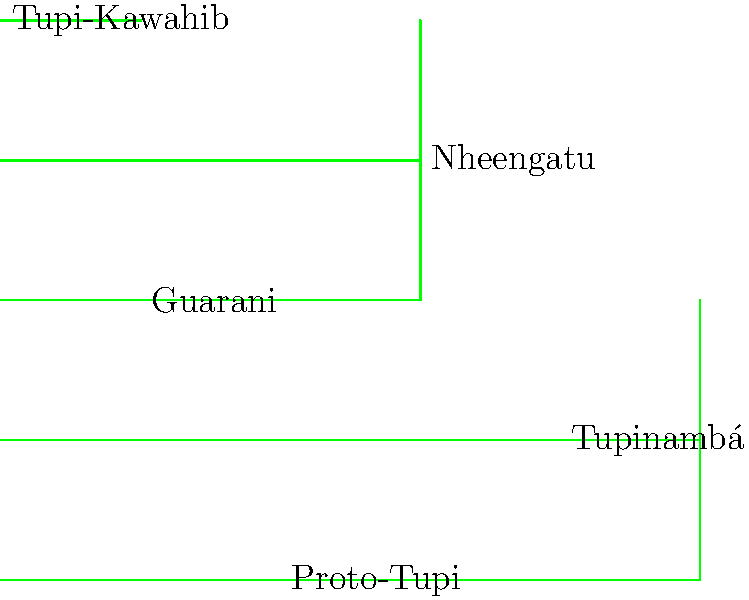Based on the dendrogram of the Tupi language family, which two languages appear to be most closely related, and what is their approximate linguistic distance? To answer this question, we need to analyze the structure of the dendrogram:

1. The dendrogram represents the relationships between languages in the Tupi family, with branches indicating linguistic distance.

2. Languages that share a common branch point earlier (towards the left) are more closely related.

3. The horizontal distance between branch points represents linguistic distance.

4. Examining the diagram, we can see that Tupinambá and Guarani share a common branch point earlier than any other pair of languages.

5. To calculate the approximate linguistic distance:
   a. Identify the x-coordinates of the branch points:
      - Tupinambá and Guarani branch at x = 5
      - Their common ancestor branches from the main trunk at x = 3
   b. Calculate the difference: 5 - 3 = 2

Therefore, Tupinambá and Guarani are the most closely related, with an approximate linguistic distance of 2 units.
Answer: Tupinambá and Guarani; 2 units 